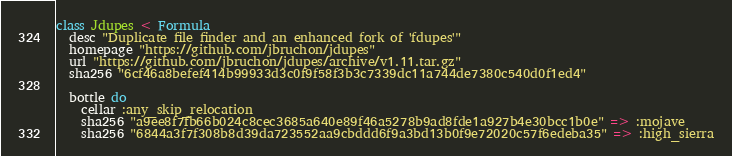Convert code to text. <code><loc_0><loc_0><loc_500><loc_500><_Ruby_>class Jdupes < Formula
  desc "Duplicate file finder and an enhanced fork of 'fdupes'"
  homepage "https://github.com/jbruchon/jdupes"
  url "https://github.com/jbruchon/jdupes/archive/v1.11.tar.gz"
  sha256 "6cf46a8befef414b99933d3c0f9f58f3b3c7339dc11a744de7380c540d0f1ed4"

  bottle do
    cellar :any_skip_relocation
    sha256 "a9ee8f7fb66b024c8cec3685a640e89f46a5278b9ad8fde1a927b4e30bcc1b0e" => :mojave
    sha256 "6844a3f7f308b8d39da723552aa9cbddd6f9a3bd13b0f9e72020c57f6edeba35" => :high_sierra</code> 